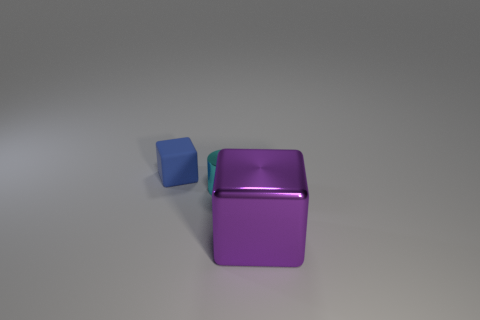Are there any other things that are the same size as the purple thing?
Your answer should be compact. No. What is the material of the thing that is behind the purple thing and in front of the tiny blue rubber cube?
Ensure brevity in your answer.  Metal. What is the color of the block that is behind the block that is in front of the cube behind the purple cube?
Provide a succinct answer. Blue. How many cyan things are either small rubber cubes or small metallic objects?
Make the answer very short. 1. What number of other objects are there of the same size as the cyan thing?
Make the answer very short. 1. How many small purple metallic objects are there?
Ensure brevity in your answer.  0. Is there anything else that is the same shape as the blue matte thing?
Your response must be concise. Yes. Is the block that is in front of the blue matte cube made of the same material as the tiny object in front of the blue block?
Offer a very short reply. Yes. What material is the cyan cylinder?
Ensure brevity in your answer.  Metal. What number of other tiny cyan cylinders have the same material as the tiny cylinder?
Keep it short and to the point. 0. 